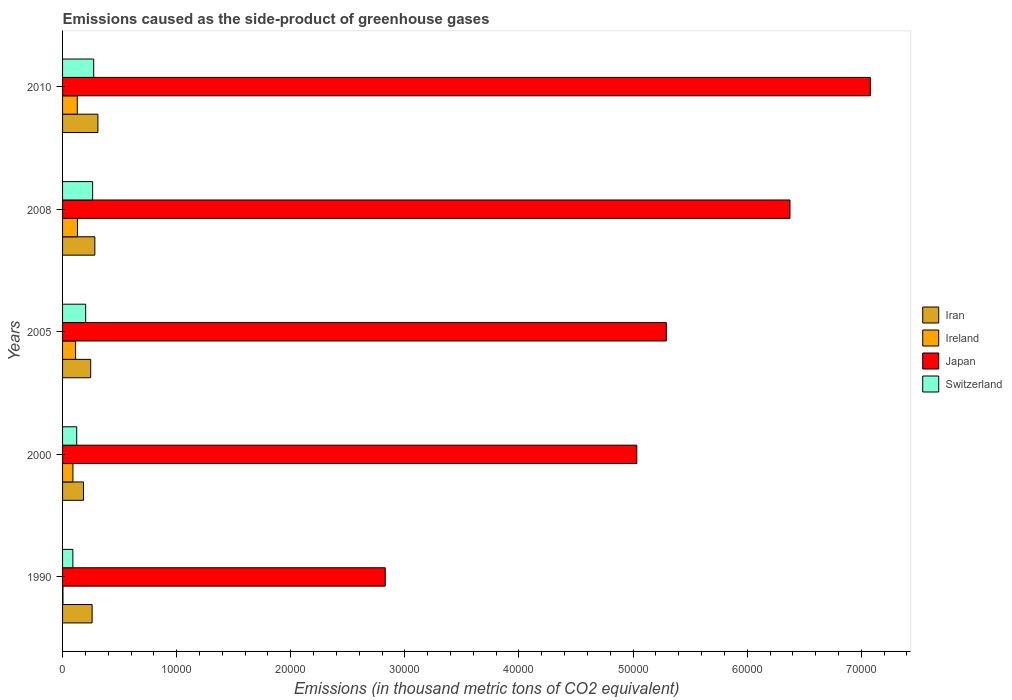How many different coloured bars are there?
Your answer should be very brief. 4. Are the number of bars on each tick of the Y-axis equal?
Ensure brevity in your answer.  Yes. How many bars are there on the 5th tick from the top?
Give a very brief answer. 4. How many bars are there on the 5th tick from the bottom?
Keep it short and to the point. 4. What is the emissions caused as the side-product of greenhouse gases in Japan in 2008?
Keep it short and to the point. 6.38e+04. Across all years, what is the maximum emissions caused as the side-product of greenhouse gases in Switzerland?
Your response must be concise. 2729. Across all years, what is the minimum emissions caused as the side-product of greenhouse gases in Ireland?
Make the answer very short. 36.4. What is the total emissions caused as the side-product of greenhouse gases in Ireland in the graph?
Keep it short and to the point. 4685.2. What is the difference between the emissions caused as the side-product of greenhouse gases in Ireland in 1990 and that in 2008?
Your answer should be compact. -1269.7. What is the difference between the emissions caused as the side-product of greenhouse gases in Iran in 2005 and the emissions caused as the side-product of greenhouse gases in Ireland in 2000?
Give a very brief answer. 1555.6. What is the average emissions caused as the side-product of greenhouse gases in Switzerland per year?
Give a very brief answer. 1905.98. In the year 1990, what is the difference between the emissions caused as the side-product of greenhouse gases in Iran and emissions caused as the side-product of greenhouse gases in Japan?
Offer a terse response. -2.57e+04. In how many years, is the emissions caused as the side-product of greenhouse gases in Switzerland greater than 14000 thousand metric tons?
Make the answer very short. 0. What is the ratio of the emissions caused as the side-product of greenhouse gases in Iran in 2000 to that in 2005?
Your response must be concise. 0.74. What is the difference between the highest and the second highest emissions caused as the side-product of greenhouse gases in Switzerland?
Keep it short and to the point. 94.9. What is the difference between the highest and the lowest emissions caused as the side-product of greenhouse gases in Iran?
Offer a terse response. 1263.6. In how many years, is the emissions caused as the side-product of greenhouse gases in Switzerland greater than the average emissions caused as the side-product of greenhouse gases in Switzerland taken over all years?
Your answer should be compact. 3. Is the sum of the emissions caused as the side-product of greenhouse gases in Ireland in 1990 and 2010 greater than the maximum emissions caused as the side-product of greenhouse gases in Japan across all years?
Your answer should be compact. No. What does the 4th bar from the top in 2008 represents?
Make the answer very short. Iran. What does the 1st bar from the bottom in 1990 represents?
Provide a short and direct response. Iran. How many years are there in the graph?
Make the answer very short. 5. Where does the legend appear in the graph?
Offer a very short reply. Center right. How many legend labels are there?
Keep it short and to the point. 4. How are the legend labels stacked?
Provide a succinct answer. Vertical. What is the title of the graph?
Provide a short and direct response. Emissions caused as the side-product of greenhouse gases. Does "Upper middle income" appear as one of the legend labels in the graph?
Your response must be concise. No. What is the label or title of the X-axis?
Keep it short and to the point. Emissions (in thousand metric tons of CO2 equivalent). What is the Emissions (in thousand metric tons of CO2 equivalent) of Iran in 1990?
Offer a terse response. 2590.8. What is the Emissions (in thousand metric tons of CO2 equivalent) of Ireland in 1990?
Keep it short and to the point. 36.4. What is the Emissions (in thousand metric tons of CO2 equivalent) in Japan in 1990?
Give a very brief answer. 2.83e+04. What is the Emissions (in thousand metric tons of CO2 equivalent) of Switzerland in 1990?
Provide a succinct answer. 902.6. What is the Emissions (in thousand metric tons of CO2 equivalent) of Iran in 2000?
Your answer should be very brief. 1833.4. What is the Emissions (in thousand metric tons of CO2 equivalent) of Ireland in 2000?
Your answer should be very brief. 908.4. What is the Emissions (in thousand metric tons of CO2 equivalent) of Japan in 2000?
Provide a short and direct response. 5.03e+04. What is the Emissions (in thousand metric tons of CO2 equivalent) of Switzerland in 2000?
Offer a very short reply. 1239.2. What is the Emissions (in thousand metric tons of CO2 equivalent) in Iran in 2005?
Give a very brief answer. 2464. What is the Emissions (in thousand metric tons of CO2 equivalent) in Ireland in 2005?
Your answer should be compact. 1143.3. What is the Emissions (in thousand metric tons of CO2 equivalent) in Japan in 2005?
Your answer should be very brief. 5.29e+04. What is the Emissions (in thousand metric tons of CO2 equivalent) of Switzerland in 2005?
Offer a terse response. 2025. What is the Emissions (in thousand metric tons of CO2 equivalent) of Iran in 2008?
Offer a terse response. 2828.5. What is the Emissions (in thousand metric tons of CO2 equivalent) in Ireland in 2008?
Your response must be concise. 1306.1. What is the Emissions (in thousand metric tons of CO2 equivalent) of Japan in 2008?
Give a very brief answer. 6.38e+04. What is the Emissions (in thousand metric tons of CO2 equivalent) in Switzerland in 2008?
Provide a short and direct response. 2634.1. What is the Emissions (in thousand metric tons of CO2 equivalent) in Iran in 2010?
Offer a terse response. 3097. What is the Emissions (in thousand metric tons of CO2 equivalent) in Ireland in 2010?
Keep it short and to the point. 1291. What is the Emissions (in thousand metric tons of CO2 equivalent) in Japan in 2010?
Offer a terse response. 7.08e+04. What is the Emissions (in thousand metric tons of CO2 equivalent) of Switzerland in 2010?
Provide a short and direct response. 2729. Across all years, what is the maximum Emissions (in thousand metric tons of CO2 equivalent) in Iran?
Offer a terse response. 3097. Across all years, what is the maximum Emissions (in thousand metric tons of CO2 equivalent) of Ireland?
Keep it short and to the point. 1306.1. Across all years, what is the maximum Emissions (in thousand metric tons of CO2 equivalent) of Japan?
Make the answer very short. 7.08e+04. Across all years, what is the maximum Emissions (in thousand metric tons of CO2 equivalent) of Switzerland?
Give a very brief answer. 2729. Across all years, what is the minimum Emissions (in thousand metric tons of CO2 equivalent) of Iran?
Offer a terse response. 1833.4. Across all years, what is the minimum Emissions (in thousand metric tons of CO2 equivalent) of Ireland?
Ensure brevity in your answer.  36.4. Across all years, what is the minimum Emissions (in thousand metric tons of CO2 equivalent) of Japan?
Your answer should be compact. 2.83e+04. Across all years, what is the minimum Emissions (in thousand metric tons of CO2 equivalent) in Switzerland?
Make the answer very short. 902.6. What is the total Emissions (in thousand metric tons of CO2 equivalent) of Iran in the graph?
Offer a very short reply. 1.28e+04. What is the total Emissions (in thousand metric tons of CO2 equivalent) of Ireland in the graph?
Your answer should be compact. 4685.2. What is the total Emissions (in thousand metric tons of CO2 equivalent) in Japan in the graph?
Provide a short and direct response. 2.66e+05. What is the total Emissions (in thousand metric tons of CO2 equivalent) in Switzerland in the graph?
Offer a very short reply. 9529.9. What is the difference between the Emissions (in thousand metric tons of CO2 equivalent) in Iran in 1990 and that in 2000?
Make the answer very short. 757.4. What is the difference between the Emissions (in thousand metric tons of CO2 equivalent) in Ireland in 1990 and that in 2000?
Keep it short and to the point. -872. What is the difference between the Emissions (in thousand metric tons of CO2 equivalent) in Japan in 1990 and that in 2000?
Make the answer very short. -2.20e+04. What is the difference between the Emissions (in thousand metric tons of CO2 equivalent) of Switzerland in 1990 and that in 2000?
Your response must be concise. -336.6. What is the difference between the Emissions (in thousand metric tons of CO2 equivalent) of Iran in 1990 and that in 2005?
Offer a terse response. 126.8. What is the difference between the Emissions (in thousand metric tons of CO2 equivalent) of Ireland in 1990 and that in 2005?
Your response must be concise. -1106.9. What is the difference between the Emissions (in thousand metric tons of CO2 equivalent) of Japan in 1990 and that in 2005?
Your response must be concise. -2.46e+04. What is the difference between the Emissions (in thousand metric tons of CO2 equivalent) of Switzerland in 1990 and that in 2005?
Give a very brief answer. -1122.4. What is the difference between the Emissions (in thousand metric tons of CO2 equivalent) of Iran in 1990 and that in 2008?
Give a very brief answer. -237.7. What is the difference between the Emissions (in thousand metric tons of CO2 equivalent) in Ireland in 1990 and that in 2008?
Make the answer very short. -1269.7. What is the difference between the Emissions (in thousand metric tons of CO2 equivalent) in Japan in 1990 and that in 2008?
Offer a terse response. -3.55e+04. What is the difference between the Emissions (in thousand metric tons of CO2 equivalent) in Switzerland in 1990 and that in 2008?
Offer a terse response. -1731.5. What is the difference between the Emissions (in thousand metric tons of CO2 equivalent) in Iran in 1990 and that in 2010?
Offer a terse response. -506.2. What is the difference between the Emissions (in thousand metric tons of CO2 equivalent) in Ireland in 1990 and that in 2010?
Your answer should be compact. -1254.6. What is the difference between the Emissions (in thousand metric tons of CO2 equivalent) in Japan in 1990 and that in 2010?
Provide a succinct answer. -4.25e+04. What is the difference between the Emissions (in thousand metric tons of CO2 equivalent) of Switzerland in 1990 and that in 2010?
Ensure brevity in your answer.  -1826.4. What is the difference between the Emissions (in thousand metric tons of CO2 equivalent) in Iran in 2000 and that in 2005?
Ensure brevity in your answer.  -630.6. What is the difference between the Emissions (in thousand metric tons of CO2 equivalent) of Ireland in 2000 and that in 2005?
Ensure brevity in your answer.  -234.9. What is the difference between the Emissions (in thousand metric tons of CO2 equivalent) in Japan in 2000 and that in 2005?
Ensure brevity in your answer.  -2588.2. What is the difference between the Emissions (in thousand metric tons of CO2 equivalent) in Switzerland in 2000 and that in 2005?
Offer a terse response. -785.8. What is the difference between the Emissions (in thousand metric tons of CO2 equivalent) of Iran in 2000 and that in 2008?
Your answer should be very brief. -995.1. What is the difference between the Emissions (in thousand metric tons of CO2 equivalent) in Ireland in 2000 and that in 2008?
Provide a succinct answer. -397.7. What is the difference between the Emissions (in thousand metric tons of CO2 equivalent) of Japan in 2000 and that in 2008?
Offer a very short reply. -1.34e+04. What is the difference between the Emissions (in thousand metric tons of CO2 equivalent) in Switzerland in 2000 and that in 2008?
Your response must be concise. -1394.9. What is the difference between the Emissions (in thousand metric tons of CO2 equivalent) in Iran in 2000 and that in 2010?
Provide a short and direct response. -1263.6. What is the difference between the Emissions (in thousand metric tons of CO2 equivalent) in Ireland in 2000 and that in 2010?
Ensure brevity in your answer.  -382.6. What is the difference between the Emissions (in thousand metric tons of CO2 equivalent) of Japan in 2000 and that in 2010?
Give a very brief answer. -2.05e+04. What is the difference between the Emissions (in thousand metric tons of CO2 equivalent) in Switzerland in 2000 and that in 2010?
Your response must be concise. -1489.8. What is the difference between the Emissions (in thousand metric tons of CO2 equivalent) in Iran in 2005 and that in 2008?
Your response must be concise. -364.5. What is the difference between the Emissions (in thousand metric tons of CO2 equivalent) in Ireland in 2005 and that in 2008?
Keep it short and to the point. -162.8. What is the difference between the Emissions (in thousand metric tons of CO2 equivalent) in Japan in 2005 and that in 2008?
Your response must be concise. -1.08e+04. What is the difference between the Emissions (in thousand metric tons of CO2 equivalent) in Switzerland in 2005 and that in 2008?
Your answer should be compact. -609.1. What is the difference between the Emissions (in thousand metric tons of CO2 equivalent) in Iran in 2005 and that in 2010?
Your answer should be very brief. -633. What is the difference between the Emissions (in thousand metric tons of CO2 equivalent) of Ireland in 2005 and that in 2010?
Your answer should be very brief. -147.7. What is the difference between the Emissions (in thousand metric tons of CO2 equivalent) of Japan in 2005 and that in 2010?
Your response must be concise. -1.79e+04. What is the difference between the Emissions (in thousand metric tons of CO2 equivalent) of Switzerland in 2005 and that in 2010?
Your answer should be compact. -704. What is the difference between the Emissions (in thousand metric tons of CO2 equivalent) in Iran in 2008 and that in 2010?
Ensure brevity in your answer.  -268.5. What is the difference between the Emissions (in thousand metric tons of CO2 equivalent) in Japan in 2008 and that in 2010?
Give a very brief answer. -7042.3. What is the difference between the Emissions (in thousand metric tons of CO2 equivalent) in Switzerland in 2008 and that in 2010?
Offer a terse response. -94.9. What is the difference between the Emissions (in thousand metric tons of CO2 equivalent) in Iran in 1990 and the Emissions (in thousand metric tons of CO2 equivalent) in Ireland in 2000?
Provide a short and direct response. 1682.4. What is the difference between the Emissions (in thousand metric tons of CO2 equivalent) of Iran in 1990 and the Emissions (in thousand metric tons of CO2 equivalent) of Japan in 2000?
Your answer should be very brief. -4.77e+04. What is the difference between the Emissions (in thousand metric tons of CO2 equivalent) in Iran in 1990 and the Emissions (in thousand metric tons of CO2 equivalent) in Switzerland in 2000?
Provide a succinct answer. 1351.6. What is the difference between the Emissions (in thousand metric tons of CO2 equivalent) of Ireland in 1990 and the Emissions (in thousand metric tons of CO2 equivalent) of Japan in 2000?
Offer a very short reply. -5.03e+04. What is the difference between the Emissions (in thousand metric tons of CO2 equivalent) of Ireland in 1990 and the Emissions (in thousand metric tons of CO2 equivalent) of Switzerland in 2000?
Ensure brevity in your answer.  -1202.8. What is the difference between the Emissions (in thousand metric tons of CO2 equivalent) of Japan in 1990 and the Emissions (in thousand metric tons of CO2 equivalent) of Switzerland in 2000?
Make the answer very short. 2.70e+04. What is the difference between the Emissions (in thousand metric tons of CO2 equivalent) in Iran in 1990 and the Emissions (in thousand metric tons of CO2 equivalent) in Ireland in 2005?
Ensure brevity in your answer.  1447.5. What is the difference between the Emissions (in thousand metric tons of CO2 equivalent) in Iran in 1990 and the Emissions (in thousand metric tons of CO2 equivalent) in Japan in 2005?
Your response must be concise. -5.03e+04. What is the difference between the Emissions (in thousand metric tons of CO2 equivalent) in Iran in 1990 and the Emissions (in thousand metric tons of CO2 equivalent) in Switzerland in 2005?
Offer a terse response. 565.8. What is the difference between the Emissions (in thousand metric tons of CO2 equivalent) in Ireland in 1990 and the Emissions (in thousand metric tons of CO2 equivalent) in Japan in 2005?
Your response must be concise. -5.29e+04. What is the difference between the Emissions (in thousand metric tons of CO2 equivalent) of Ireland in 1990 and the Emissions (in thousand metric tons of CO2 equivalent) of Switzerland in 2005?
Give a very brief answer. -1988.6. What is the difference between the Emissions (in thousand metric tons of CO2 equivalent) of Japan in 1990 and the Emissions (in thousand metric tons of CO2 equivalent) of Switzerland in 2005?
Provide a succinct answer. 2.63e+04. What is the difference between the Emissions (in thousand metric tons of CO2 equivalent) in Iran in 1990 and the Emissions (in thousand metric tons of CO2 equivalent) in Ireland in 2008?
Provide a short and direct response. 1284.7. What is the difference between the Emissions (in thousand metric tons of CO2 equivalent) in Iran in 1990 and the Emissions (in thousand metric tons of CO2 equivalent) in Japan in 2008?
Your answer should be compact. -6.12e+04. What is the difference between the Emissions (in thousand metric tons of CO2 equivalent) in Iran in 1990 and the Emissions (in thousand metric tons of CO2 equivalent) in Switzerland in 2008?
Your response must be concise. -43.3. What is the difference between the Emissions (in thousand metric tons of CO2 equivalent) of Ireland in 1990 and the Emissions (in thousand metric tons of CO2 equivalent) of Japan in 2008?
Provide a short and direct response. -6.37e+04. What is the difference between the Emissions (in thousand metric tons of CO2 equivalent) in Ireland in 1990 and the Emissions (in thousand metric tons of CO2 equivalent) in Switzerland in 2008?
Your answer should be very brief. -2597.7. What is the difference between the Emissions (in thousand metric tons of CO2 equivalent) in Japan in 1990 and the Emissions (in thousand metric tons of CO2 equivalent) in Switzerland in 2008?
Make the answer very short. 2.56e+04. What is the difference between the Emissions (in thousand metric tons of CO2 equivalent) of Iran in 1990 and the Emissions (in thousand metric tons of CO2 equivalent) of Ireland in 2010?
Provide a short and direct response. 1299.8. What is the difference between the Emissions (in thousand metric tons of CO2 equivalent) of Iran in 1990 and the Emissions (in thousand metric tons of CO2 equivalent) of Japan in 2010?
Keep it short and to the point. -6.82e+04. What is the difference between the Emissions (in thousand metric tons of CO2 equivalent) in Iran in 1990 and the Emissions (in thousand metric tons of CO2 equivalent) in Switzerland in 2010?
Your answer should be compact. -138.2. What is the difference between the Emissions (in thousand metric tons of CO2 equivalent) of Ireland in 1990 and the Emissions (in thousand metric tons of CO2 equivalent) of Japan in 2010?
Ensure brevity in your answer.  -7.08e+04. What is the difference between the Emissions (in thousand metric tons of CO2 equivalent) in Ireland in 1990 and the Emissions (in thousand metric tons of CO2 equivalent) in Switzerland in 2010?
Your answer should be very brief. -2692.6. What is the difference between the Emissions (in thousand metric tons of CO2 equivalent) of Japan in 1990 and the Emissions (in thousand metric tons of CO2 equivalent) of Switzerland in 2010?
Your answer should be very brief. 2.56e+04. What is the difference between the Emissions (in thousand metric tons of CO2 equivalent) of Iran in 2000 and the Emissions (in thousand metric tons of CO2 equivalent) of Ireland in 2005?
Give a very brief answer. 690.1. What is the difference between the Emissions (in thousand metric tons of CO2 equivalent) in Iran in 2000 and the Emissions (in thousand metric tons of CO2 equivalent) in Japan in 2005?
Make the answer very short. -5.11e+04. What is the difference between the Emissions (in thousand metric tons of CO2 equivalent) in Iran in 2000 and the Emissions (in thousand metric tons of CO2 equivalent) in Switzerland in 2005?
Make the answer very short. -191.6. What is the difference between the Emissions (in thousand metric tons of CO2 equivalent) in Ireland in 2000 and the Emissions (in thousand metric tons of CO2 equivalent) in Japan in 2005?
Give a very brief answer. -5.20e+04. What is the difference between the Emissions (in thousand metric tons of CO2 equivalent) in Ireland in 2000 and the Emissions (in thousand metric tons of CO2 equivalent) in Switzerland in 2005?
Give a very brief answer. -1116.6. What is the difference between the Emissions (in thousand metric tons of CO2 equivalent) in Japan in 2000 and the Emissions (in thousand metric tons of CO2 equivalent) in Switzerland in 2005?
Your response must be concise. 4.83e+04. What is the difference between the Emissions (in thousand metric tons of CO2 equivalent) in Iran in 2000 and the Emissions (in thousand metric tons of CO2 equivalent) in Ireland in 2008?
Provide a succinct answer. 527.3. What is the difference between the Emissions (in thousand metric tons of CO2 equivalent) of Iran in 2000 and the Emissions (in thousand metric tons of CO2 equivalent) of Japan in 2008?
Make the answer very short. -6.19e+04. What is the difference between the Emissions (in thousand metric tons of CO2 equivalent) in Iran in 2000 and the Emissions (in thousand metric tons of CO2 equivalent) in Switzerland in 2008?
Your response must be concise. -800.7. What is the difference between the Emissions (in thousand metric tons of CO2 equivalent) of Ireland in 2000 and the Emissions (in thousand metric tons of CO2 equivalent) of Japan in 2008?
Provide a short and direct response. -6.28e+04. What is the difference between the Emissions (in thousand metric tons of CO2 equivalent) of Ireland in 2000 and the Emissions (in thousand metric tons of CO2 equivalent) of Switzerland in 2008?
Provide a succinct answer. -1725.7. What is the difference between the Emissions (in thousand metric tons of CO2 equivalent) in Japan in 2000 and the Emissions (in thousand metric tons of CO2 equivalent) in Switzerland in 2008?
Make the answer very short. 4.77e+04. What is the difference between the Emissions (in thousand metric tons of CO2 equivalent) of Iran in 2000 and the Emissions (in thousand metric tons of CO2 equivalent) of Ireland in 2010?
Keep it short and to the point. 542.4. What is the difference between the Emissions (in thousand metric tons of CO2 equivalent) in Iran in 2000 and the Emissions (in thousand metric tons of CO2 equivalent) in Japan in 2010?
Make the answer very short. -6.90e+04. What is the difference between the Emissions (in thousand metric tons of CO2 equivalent) in Iran in 2000 and the Emissions (in thousand metric tons of CO2 equivalent) in Switzerland in 2010?
Provide a short and direct response. -895.6. What is the difference between the Emissions (in thousand metric tons of CO2 equivalent) of Ireland in 2000 and the Emissions (in thousand metric tons of CO2 equivalent) of Japan in 2010?
Ensure brevity in your answer.  -6.99e+04. What is the difference between the Emissions (in thousand metric tons of CO2 equivalent) of Ireland in 2000 and the Emissions (in thousand metric tons of CO2 equivalent) of Switzerland in 2010?
Offer a terse response. -1820.6. What is the difference between the Emissions (in thousand metric tons of CO2 equivalent) of Japan in 2000 and the Emissions (in thousand metric tons of CO2 equivalent) of Switzerland in 2010?
Keep it short and to the point. 4.76e+04. What is the difference between the Emissions (in thousand metric tons of CO2 equivalent) in Iran in 2005 and the Emissions (in thousand metric tons of CO2 equivalent) in Ireland in 2008?
Keep it short and to the point. 1157.9. What is the difference between the Emissions (in thousand metric tons of CO2 equivalent) of Iran in 2005 and the Emissions (in thousand metric tons of CO2 equivalent) of Japan in 2008?
Your answer should be compact. -6.13e+04. What is the difference between the Emissions (in thousand metric tons of CO2 equivalent) of Iran in 2005 and the Emissions (in thousand metric tons of CO2 equivalent) of Switzerland in 2008?
Offer a terse response. -170.1. What is the difference between the Emissions (in thousand metric tons of CO2 equivalent) of Ireland in 2005 and the Emissions (in thousand metric tons of CO2 equivalent) of Japan in 2008?
Your answer should be compact. -6.26e+04. What is the difference between the Emissions (in thousand metric tons of CO2 equivalent) in Ireland in 2005 and the Emissions (in thousand metric tons of CO2 equivalent) in Switzerland in 2008?
Your response must be concise. -1490.8. What is the difference between the Emissions (in thousand metric tons of CO2 equivalent) of Japan in 2005 and the Emissions (in thousand metric tons of CO2 equivalent) of Switzerland in 2008?
Your answer should be very brief. 5.03e+04. What is the difference between the Emissions (in thousand metric tons of CO2 equivalent) in Iran in 2005 and the Emissions (in thousand metric tons of CO2 equivalent) in Ireland in 2010?
Ensure brevity in your answer.  1173. What is the difference between the Emissions (in thousand metric tons of CO2 equivalent) of Iran in 2005 and the Emissions (in thousand metric tons of CO2 equivalent) of Japan in 2010?
Your answer should be compact. -6.83e+04. What is the difference between the Emissions (in thousand metric tons of CO2 equivalent) of Iran in 2005 and the Emissions (in thousand metric tons of CO2 equivalent) of Switzerland in 2010?
Make the answer very short. -265. What is the difference between the Emissions (in thousand metric tons of CO2 equivalent) in Ireland in 2005 and the Emissions (in thousand metric tons of CO2 equivalent) in Japan in 2010?
Your response must be concise. -6.96e+04. What is the difference between the Emissions (in thousand metric tons of CO2 equivalent) of Ireland in 2005 and the Emissions (in thousand metric tons of CO2 equivalent) of Switzerland in 2010?
Your answer should be compact. -1585.7. What is the difference between the Emissions (in thousand metric tons of CO2 equivalent) of Japan in 2005 and the Emissions (in thousand metric tons of CO2 equivalent) of Switzerland in 2010?
Offer a terse response. 5.02e+04. What is the difference between the Emissions (in thousand metric tons of CO2 equivalent) in Iran in 2008 and the Emissions (in thousand metric tons of CO2 equivalent) in Ireland in 2010?
Offer a terse response. 1537.5. What is the difference between the Emissions (in thousand metric tons of CO2 equivalent) of Iran in 2008 and the Emissions (in thousand metric tons of CO2 equivalent) of Japan in 2010?
Provide a succinct answer. -6.80e+04. What is the difference between the Emissions (in thousand metric tons of CO2 equivalent) in Iran in 2008 and the Emissions (in thousand metric tons of CO2 equivalent) in Switzerland in 2010?
Give a very brief answer. 99.5. What is the difference between the Emissions (in thousand metric tons of CO2 equivalent) of Ireland in 2008 and the Emissions (in thousand metric tons of CO2 equivalent) of Japan in 2010?
Your answer should be very brief. -6.95e+04. What is the difference between the Emissions (in thousand metric tons of CO2 equivalent) in Ireland in 2008 and the Emissions (in thousand metric tons of CO2 equivalent) in Switzerland in 2010?
Your response must be concise. -1422.9. What is the difference between the Emissions (in thousand metric tons of CO2 equivalent) of Japan in 2008 and the Emissions (in thousand metric tons of CO2 equivalent) of Switzerland in 2010?
Ensure brevity in your answer.  6.10e+04. What is the average Emissions (in thousand metric tons of CO2 equivalent) of Iran per year?
Offer a very short reply. 2562.74. What is the average Emissions (in thousand metric tons of CO2 equivalent) in Ireland per year?
Your answer should be compact. 937.04. What is the average Emissions (in thousand metric tons of CO2 equivalent) of Japan per year?
Provide a succinct answer. 5.32e+04. What is the average Emissions (in thousand metric tons of CO2 equivalent) of Switzerland per year?
Your answer should be compact. 1905.98. In the year 1990, what is the difference between the Emissions (in thousand metric tons of CO2 equivalent) of Iran and Emissions (in thousand metric tons of CO2 equivalent) of Ireland?
Your answer should be compact. 2554.4. In the year 1990, what is the difference between the Emissions (in thousand metric tons of CO2 equivalent) in Iran and Emissions (in thousand metric tons of CO2 equivalent) in Japan?
Ensure brevity in your answer.  -2.57e+04. In the year 1990, what is the difference between the Emissions (in thousand metric tons of CO2 equivalent) of Iran and Emissions (in thousand metric tons of CO2 equivalent) of Switzerland?
Provide a succinct answer. 1688.2. In the year 1990, what is the difference between the Emissions (in thousand metric tons of CO2 equivalent) of Ireland and Emissions (in thousand metric tons of CO2 equivalent) of Japan?
Your answer should be very brief. -2.82e+04. In the year 1990, what is the difference between the Emissions (in thousand metric tons of CO2 equivalent) of Ireland and Emissions (in thousand metric tons of CO2 equivalent) of Switzerland?
Offer a very short reply. -866.2. In the year 1990, what is the difference between the Emissions (in thousand metric tons of CO2 equivalent) of Japan and Emissions (in thousand metric tons of CO2 equivalent) of Switzerland?
Provide a short and direct response. 2.74e+04. In the year 2000, what is the difference between the Emissions (in thousand metric tons of CO2 equivalent) in Iran and Emissions (in thousand metric tons of CO2 equivalent) in Ireland?
Offer a very short reply. 925. In the year 2000, what is the difference between the Emissions (in thousand metric tons of CO2 equivalent) of Iran and Emissions (in thousand metric tons of CO2 equivalent) of Japan?
Give a very brief answer. -4.85e+04. In the year 2000, what is the difference between the Emissions (in thousand metric tons of CO2 equivalent) of Iran and Emissions (in thousand metric tons of CO2 equivalent) of Switzerland?
Keep it short and to the point. 594.2. In the year 2000, what is the difference between the Emissions (in thousand metric tons of CO2 equivalent) in Ireland and Emissions (in thousand metric tons of CO2 equivalent) in Japan?
Provide a short and direct response. -4.94e+04. In the year 2000, what is the difference between the Emissions (in thousand metric tons of CO2 equivalent) in Ireland and Emissions (in thousand metric tons of CO2 equivalent) in Switzerland?
Give a very brief answer. -330.8. In the year 2000, what is the difference between the Emissions (in thousand metric tons of CO2 equivalent) in Japan and Emissions (in thousand metric tons of CO2 equivalent) in Switzerland?
Keep it short and to the point. 4.91e+04. In the year 2005, what is the difference between the Emissions (in thousand metric tons of CO2 equivalent) of Iran and Emissions (in thousand metric tons of CO2 equivalent) of Ireland?
Offer a very short reply. 1320.7. In the year 2005, what is the difference between the Emissions (in thousand metric tons of CO2 equivalent) of Iran and Emissions (in thousand metric tons of CO2 equivalent) of Japan?
Give a very brief answer. -5.05e+04. In the year 2005, what is the difference between the Emissions (in thousand metric tons of CO2 equivalent) of Iran and Emissions (in thousand metric tons of CO2 equivalent) of Switzerland?
Keep it short and to the point. 439. In the year 2005, what is the difference between the Emissions (in thousand metric tons of CO2 equivalent) of Ireland and Emissions (in thousand metric tons of CO2 equivalent) of Japan?
Offer a terse response. -5.18e+04. In the year 2005, what is the difference between the Emissions (in thousand metric tons of CO2 equivalent) in Ireland and Emissions (in thousand metric tons of CO2 equivalent) in Switzerland?
Offer a terse response. -881.7. In the year 2005, what is the difference between the Emissions (in thousand metric tons of CO2 equivalent) of Japan and Emissions (in thousand metric tons of CO2 equivalent) of Switzerland?
Keep it short and to the point. 5.09e+04. In the year 2008, what is the difference between the Emissions (in thousand metric tons of CO2 equivalent) of Iran and Emissions (in thousand metric tons of CO2 equivalent) of Ireland?
Offer a terse response. 1522.4. In the year 2008, what is the difference between the Emissions (in thousand metric tons of CO2 equivalent) in Iran and Emissions (in thousand metric tons of CO2 equivalent) in Japan?
Make the answer very short. -6.09e+04. In the year 2008, what is the difference between the Emissions (in thousand metric tons of CO2 equivalent) in Iran and Emissions (in thousand metric tons of CO2 equivalent) in Switzerland?
Give a very brief answer. 194.4. In the year 2008, what is the difference between the Emissions (in thousand metric tons of CO2 equivalent) of Ireland and Emissions (in thousand metric tons of CO2 equivalent) of Japan?
Provide a short and direct response. -6.24e+04. In the year 2008, what is the difference between the Emissions (in thousand metric tons of CO2 equivalent) of Ireland and Emissions (in thousand metric tons of CO2 equivalent) of Switzerland?
Give a very brief answer. -1328. In the year 2008, what is the difference between the Emissions (in thousand metric tons of CO2 equivalent) in Japan and Emissions (in thousand metric tons of CO2 equivalent) in Switzerland?
Your response must be concise. 6.11e+04. In the year 2010, what is the difference between the Emissions (in thousand metric tons of CO2 equivalent) in Iran and Emissions (in thousand metric tons of CO2 equivalent) in Ireland?
Make the answer very short. 1806. In the year 2010, what is the difference between the Emissions (in thousand metric tons of CO2 equivalent) of Iran and Emissions (in thousand metric tons of CO2 equivalent) of Japan?
Your answer should be very brief. -6.77e+04. In the year 2010, what is the difference between the Emissions (in thousand metric tons of CO2 equivalent) in Iran and Emissions (in thousand metric tons of CO2 equivalent) in Switzerland?
Your answer should be compact. 368. In the year 2010, what is the difference between the Emissions (in thousand metric tons of CO2 equivalent) of Ireland and Emissions (in thousand metric tons of CO2 equivalent) of Japan?
Your answer should be very brief. -6.95e+04. In the year 2010, what is the difference between the Emissions (in thousand metric tons of CO2 equivalent) in Ireland and Emissions (in thousand metric tons of CO2 equivalent) in Switzerland?
Give a very brief answer. -1438. In the year 2010, what is the difference between the Emissions (in thousand metric tons of CO2 equivalent) in Japan and Emissions (in thousand metric tons of CO2 equivalent) in Switzerland?
Ensure brevity in your answer.  6.81e+04. What is the ratio of the Emissions (in thousand metric tons of CO2 equivalent) in Iran in 1990 to that in 2000?
Your answer should be very brief. 1.41. What is the ratio of the Emissions (in thousand metric tons of CO2 equivalent) in Ireland in 1990 to that in 2000?
Provide a short and direct response. 0.04. What is the ratio of the Emissions (in thousand metric tons of CO2 equivalent) in Japan in 1990 to that in 2000?
Provide a succinct answer. 0.56. What is the ratio of the Emissions (in thousand metric tons of CO2 equivalent) in Switzerland in 1990 to that in 2000?
Provide a succinct answer. 0.73. What is the ratio of the Emissions (in thousand metric tons of CO2 equivalent) of Iran in 1990 to that in 2005?
Give a very brief answer. 1.05. What is the ratio of the Emissions (in thousand metric tons of CO2 equivalent) of Ireland in 1990 to that in 2005?
Keep it short and to the point. 0.03. What is the ratio of the Emissions (in thousand metric tons of CO2 equivalent) in Japan in 1990 to that in 2005?
Your answer should be very brief. 0.53. What is the ratio of the Emissions (in thousand metric tons of CO2 equivalent) in Switzerland in 1990 to that in 2005?
Give a very brief answer. 0.45. What is the ratio of the Emissions (in thousand metric tons of CO2 equivalent) in Iran in 1990 to that in 2008?
Provide a succinct answer. 0.92. What is the ratio of the Emissions (in thousand metric tons of CO2 equivalent) in Ireland in 1990 to that in 2008?
Your answer should be very brief. 0.03. What is the ratio of the Emissions (in thousand metric tons of CO2 equivalent) in Japan in 1990 to that in 2008?
Give a very brief answer. 0.44. What is the ratio of the Emissions (in thousand metric tons of CO2 equivalent) in Switzerland in 1990 to that in 2008?
Make the answer very short. 0.34. What is the ratio of the Emissions (in thousand metric tons of CO2 equivalent) in Iran in 1990 to that in 2010?
Make the answer very short. 0.84. What is the ratio of the Emissions (in thousand metric tons of CO2 equivalent) of Ireland in 1990 to that in 2010?
Give a very brief answer. 0.03. What is the ratio of the Emissions (in thousand metric tons of CO2 equivalent) in Japan in 1990 to that in 2010?
Your answer should be compact. 0.4. What is the ratio of the Emissions (in thousand metric tons of CO2 equivalent) in Switzerland in 1990 to that in 2010?
Ensure brevity in your answer.  0.33. What is the ratio of the Emissions (in thousand metric tons of CO2 equivalent) in Iran in 2000 to that in 2005?
Your response must be concise. 0.74. What is the ratio of the Emissions (in thousand metric tons of CO2 equivalent) in Ireland in 2000 to that in 2005?
Offer a terse response. 0.79. What is the ratio of the Emissions (in thousand metric tons of CO2 equivalent) in Japan in 2000 to that in 2005?
Ensure brevity in your answer.  0.95. What is the ratio of the Emissions (in thousand metric tons of CO2 equivalent) in Switzerland in 2000 to that in 2005?
Keep it short and to the point. 0.61. What is the ratio of the Emissions (in thousand metric tons of CO2 equivalent) in Iran in 2000 to that in 2008?
Your answer should be compact. 0.65. What is the ratio of the Emissions (in thousand metric tons of CO2 equivalent) of Ireland in 2000 to that in 2008?
Give a very brief answer. 0.7. What is the ratio of the Emissions (in thousand metric tons of CO2 equivalent) in Japan in 2000 to that in 2008?
Ensure brevity in your answer.  0.79. What is the ratio of the Emissions (in thousand metric tons of CO2 equivalent) in Switzerland in 2000 to that in 2008?
Offer a very short reply. 0.47. What is the ratio of the Emissions (in thousand metric tons of CO2 equivalent) in Iran in 2000 to that in 2010?
Make the answer very short. 0.59. What is the ratio of the Emissions (in thousand metric tons of CO2 equivalent) in Ireland in 2000 to that in 2010?
Offer a terse response. 0.7. What is the ratio of the Emissions (in thousand metric tons of CO2 equivalent) of Japan in 2000 to that in 2010?
Provide a succinct answer. 0.71. What is the ratio of the Emissions (in thousand metric tons of CO2 equivalent) of Switzerland in 2000 to that in 2010?
Keep it short and to the point. 0.45. What is the ratio of the Emissions (in thousand metric tons of CO2 equivalent) in Iran in 2005 to that in 2008?
Give a very brief answer. 0.87. What is the ratio of the Emissions (in thousand metric tons of CO2 equivalent) in Ireland in 2005 to that in 2008?
Keep it short and to the point. 0.88. What is the ratio of the Emissions (in thousand metric tons of CO2 equivalent) in Japan in 2005 to that in 2008?
Give a very brief answer. 0.83. What is the ratio of the Emissions (in thousand metric tons of CO2 equivalent) of Switzerland in 2005 to that in 2008?
Provide a succinct answer. 0.77. What is the ratio of the Emissions (in thousand metric tons of CO2 equivalent) of Iran in 2005 to that in 2010?
Ensure brevity in your answer.  0.8. What is the ratio of the Emissions (in thousand metric tons of CO2 equivalent) in Ireland in 2005 to that in 2010?
Give a very brief answer. 0.89. What is the ratio of the Emissions (in thousand metric tons of CO2 equivalent) in Japan in 2005 to that in 2010?
Ensure brevity in your answer.  0.75. What is the ratio of the Emissions (in thousand metric tons of CO2 equivalent) in Switzerland in 2005 to that in 2010?
Keep it short and to the point. 0.74. What is the ratio of the Emissions (in thousand metric tons of CO2 equivalent) of Iran in 2008 to that in 2010?
Make the answer very short. 0.91. What is the ratio of the Emissions (in thousand metric tons of CO2 equivalent) of Ireland in 2008 to that in 2010?
Offer a terse response. 1.01. What is the ratio of the Emissions (in thousand metric tons of CO2 equivalent) in Japan in 2008 to that in 2010?
Offer a terse response. 0.9. What is the ratio of the Emissions (in thousand metric tons of CO2 equivalent) of Switzerland in 2008 to that in 2010?
Your answer should be compact. 0.97. What is the difference between the highest and the second highest Emissions (in thousand metric tons of CO2 equivalent) in Iran?
Your response must be concise. 268.5. What is the difference between the highest and the second highest Emissions (in thousand metric tons of CO2 equivalent) of Ireland?
Your answer should be compact. 15.1. What is the difference between the highest and the second highest Emissions (in thousand metric tons of CO2 equivalent) in Japan?
Offer a terse response. 7042.3. What is the difference between the highest and the second highest Emissions (in thousand metric tons of CO2 equivalent) in Switzerland?
Your answer should be very brief. 94.9. What is the difference between the highest and the lowest Emissions (in thousand metric tons of CO2 equivalent) in Iran?
Your answer should be very brief. 1263.6. What is the difference between the highest and the lowest Emissions (in thousand metric tons of CO2 equivalent) in Ireland?
Offer a very short reply. 1269.7. What is the difference between the highest and the lowest Emissions (in thousand metric tons of CO2 equivalent) of Japan?
Provide a succinct answer. 4.25e+04. What is the difference between the highest and the lowest Emissions (in thousand metric tons of CO2 equivalent) in Switzerland?
Offer a very short reply. 1826.4. 